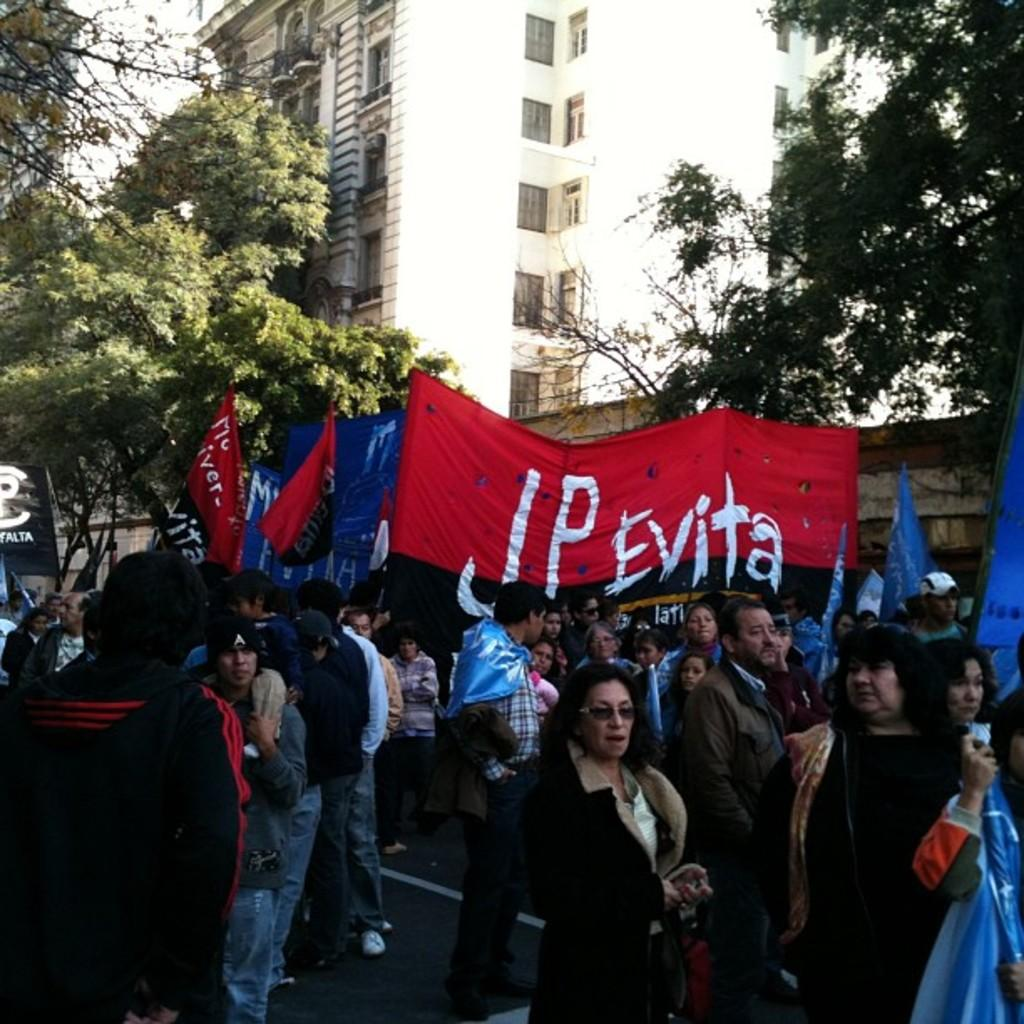How many people are in the image? There is a group of persons in the image. What are the persons in the image doing? The persons are standing and walking. What are the persons holding in the image? The persons are holding banners. What can be seen on the banners? There is text written on the banners. What is visible in the background of the image? There is a building and trees in the background of the image. How many porters are visible in the image? There are no porters present in the image. What type of bulb is used to illuminate the text on the banners? There is no information about the type of bulb used to illuminate the text on the banners, as the image does not show any lighting sources. 